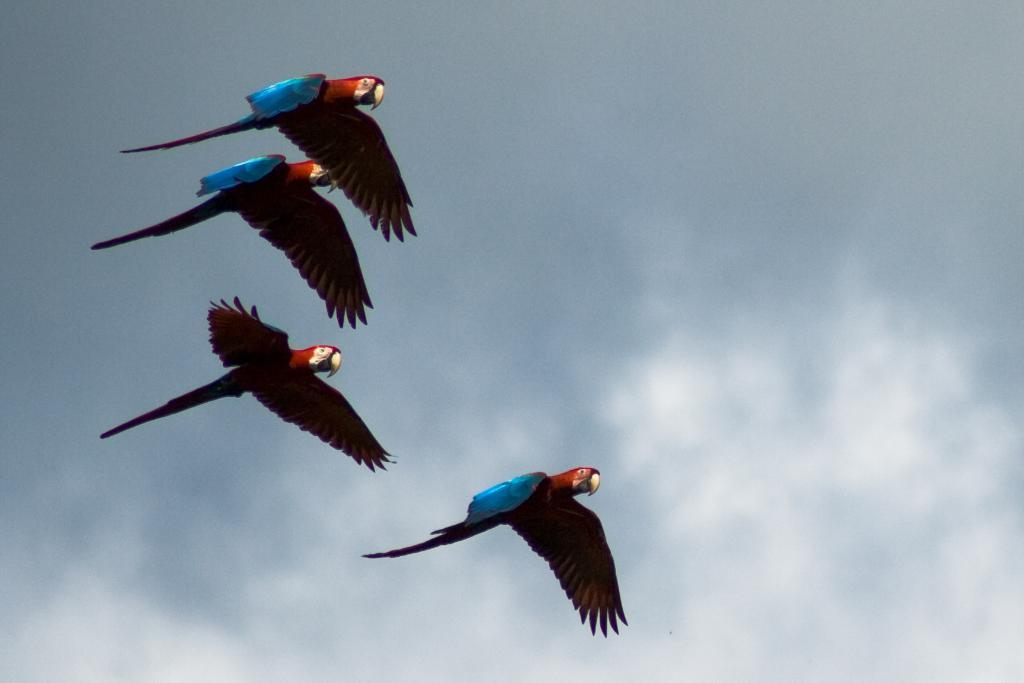What is happening in the sky in the image? There are birds flying in the air in the image. What else can be seen in the sky? The sky is visible in the image, and there are clouds in the sky. Where is the squirrel holding its party in the image? There is no squirrel or party present in the image. What type of body is visible in the image? There is no specific body visible in the image; it features birds flying in the sky. 